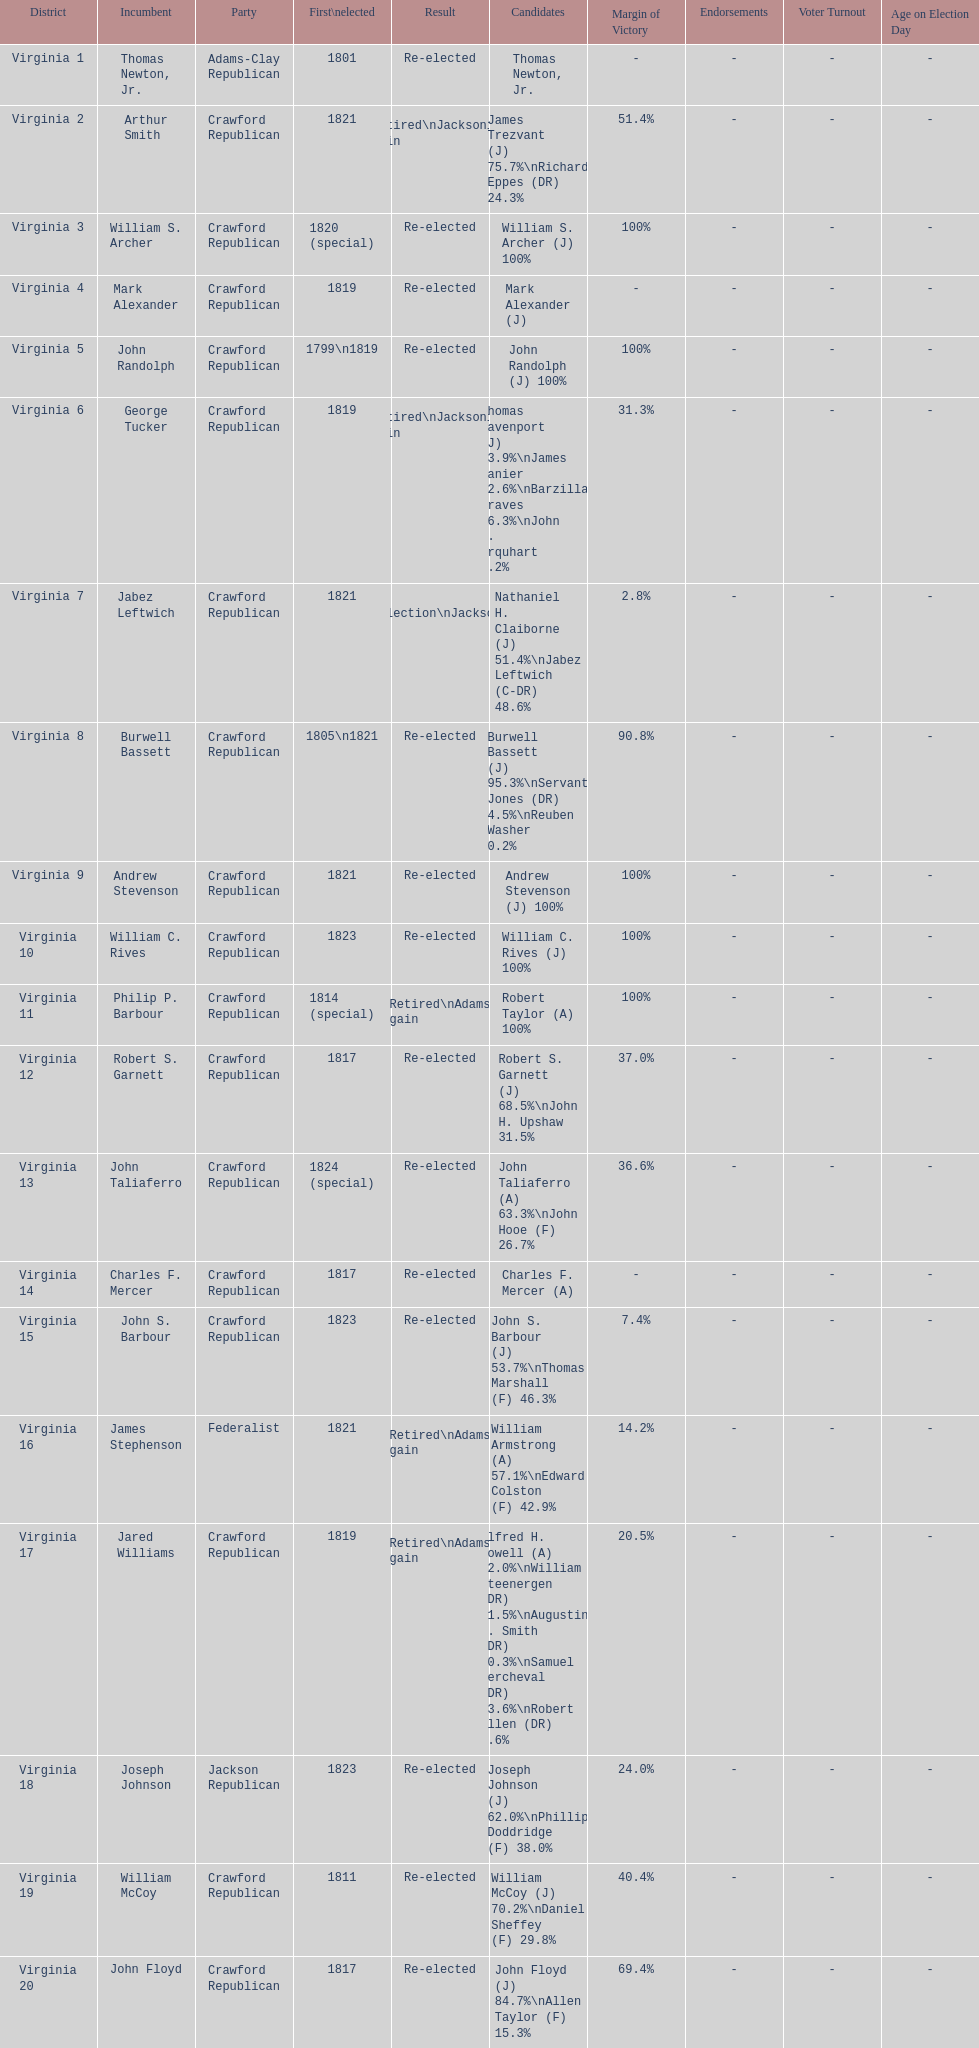What is the concluding party on this chart? Crawford Republican. 